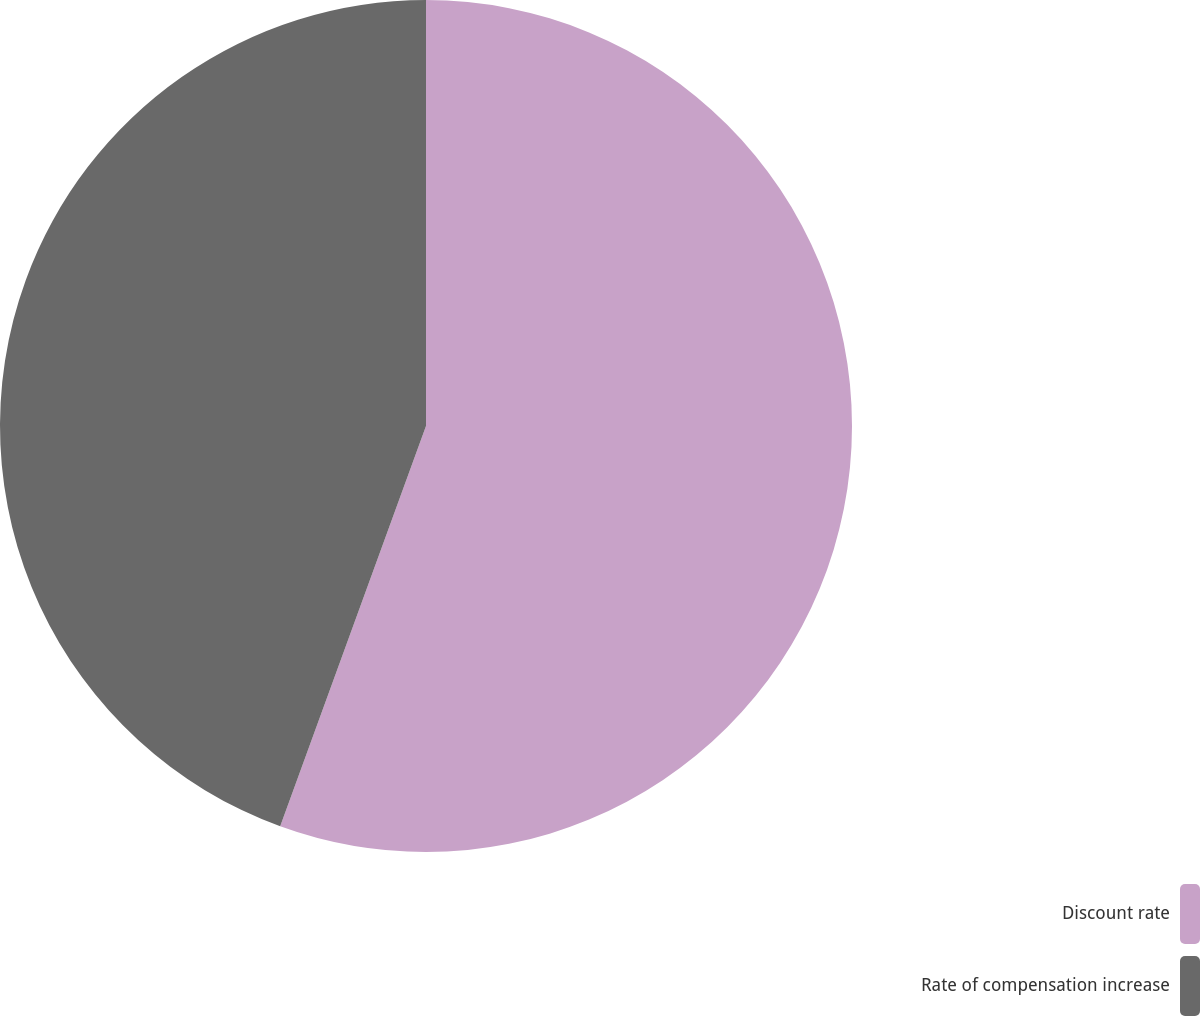Convert chart to OTSL. <chart><loc_0><loc_0><loc_500><loc_500><pie_chart><fcel>Discount rate<fcel>Rate of compensation increase<nl><fcel>55.56%<fcel>44.44%<nl></chart> 